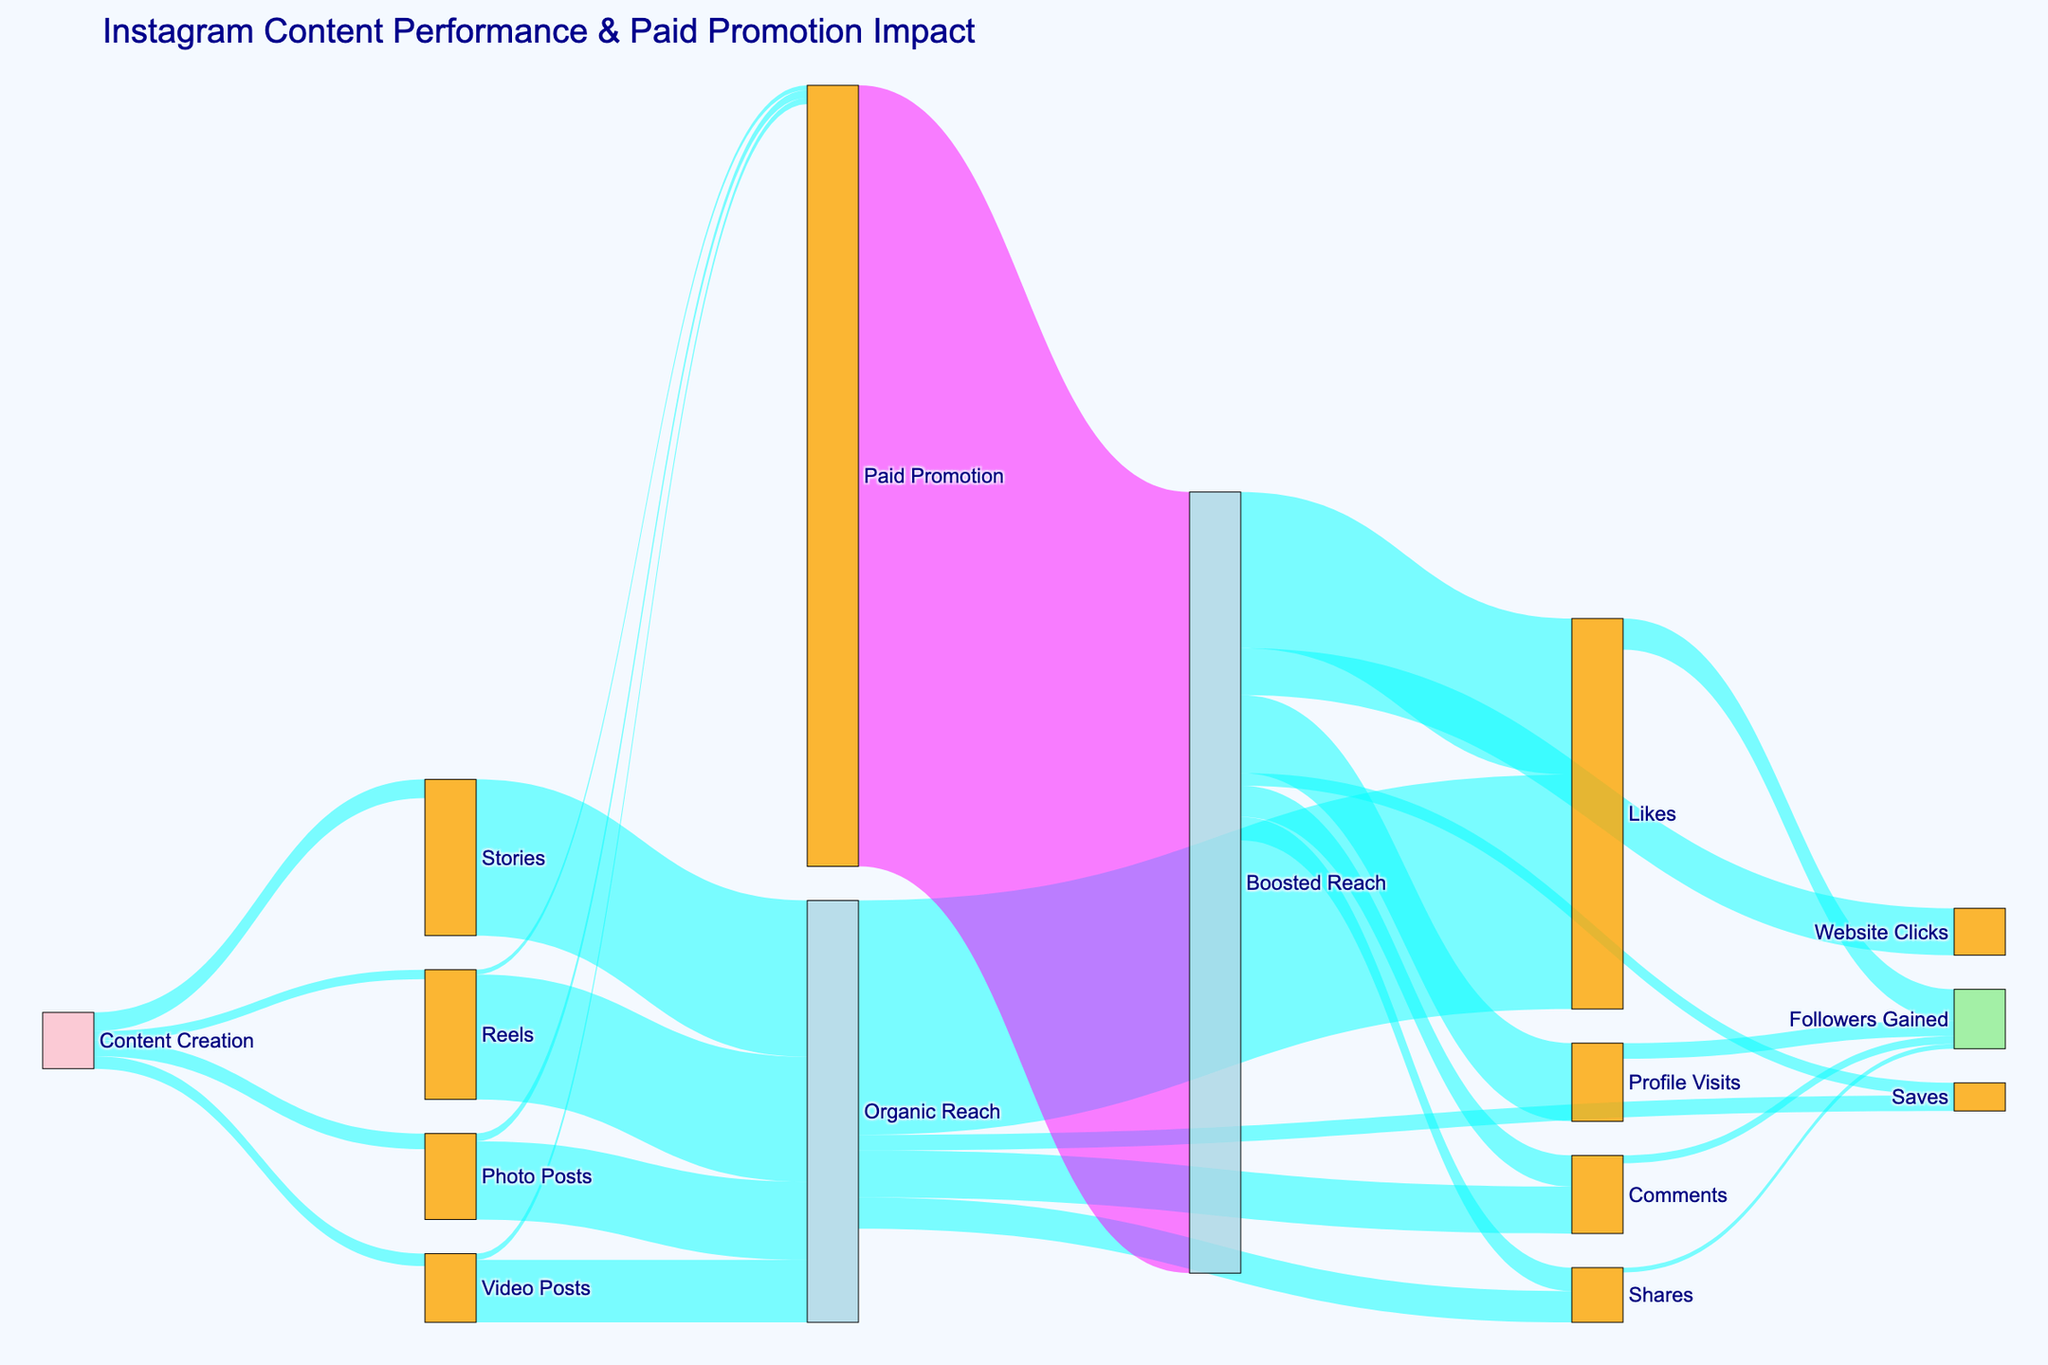What is the title of the figure? The title is located at the top of the figure and provides a brief description of the overarching topic or content. In this case, it describes the flow and impact of Instagram content and paid promotion.
Answer: Instagram Content Performance & Paid Promotion Impact What are the four types of content shown in the figure? The figure starts with "Content Creation" flowing into four different types of content types. These nodes are directly connected to "Content Creation".
Answer: Photo Posts, Video Posts, Reels, Stories How many followers gained are attributed to Likes? Likes flow to Followers Gained in the figure, which shows the amount of followers that Likes contributed to.
Answer: 2000 What is the sum of followers gained through Likes, Comments, Shares, and Profile Visits? Add up the followers contributed from each steps: Likes (2000), Comments (500), Shares (300), and Profile Visits (1000).
Answer: 3800 Which content type appears to get the most Paid Promotion? The Paid Promotion node has flows from Photo Posts, Video Posts, and Reels. By comparing the flow values visually, the top contributing content type can be identified.
Answer: Photo Posts Compare Organic Reach of Reels with Organic Reach of Stories. Which one is higher? Check the link labels originating from the Reels and Stories nodes to Organic Reach and compare their values.
Answer: Stories What is the aggregate reach (Organic + Boosted) for Reels? For Reels, sum the values flowing into Organic Reach and Paid Promotion, then include the specific Boosted Reach value that originates from Paid Promotion.
Answer: 8000 (Organic) + 300 (Paid) + 50000(Booted Reach) = 58300 Which type of engagement has the least contribution to Followers Gained? Look at the nodes leading to Followers Gained and identify which one has the lowest value flowing into it.
Answer: Shares What is the ratio of Organic Likes to Boosted Likes? Compare the values separately flowing into Likes from Organic Reach and Boosted Reach, then calculate the ratio between them.
Answer: 15000 (Organic) / 10000 (Boosted Reach) = 1.5 Look at the different types of interactions (Likes, Comments, Shares, Saves) coming from Organic Reach and Boosted Reach. Which interaction shows a higher percentage increase due to Boosted Reach? Calculate the percentage increase for each interaction by comparing the values from Organic Reach and Boosted Reach, then determine the type with the highest increase. (Formula for increase % = (Boosted Value - Organic Value)/Organic Value * 100)
Answer: Saves (800 - 1000)/1000 = -20% (Likes), (2000 - 3000)/3000 = -33.33% (Comments), (1500 - 2000)/2000 = -25% (Shares), (5000 - 1000)/1000 = 400% (Saves) 